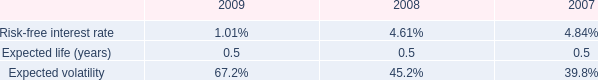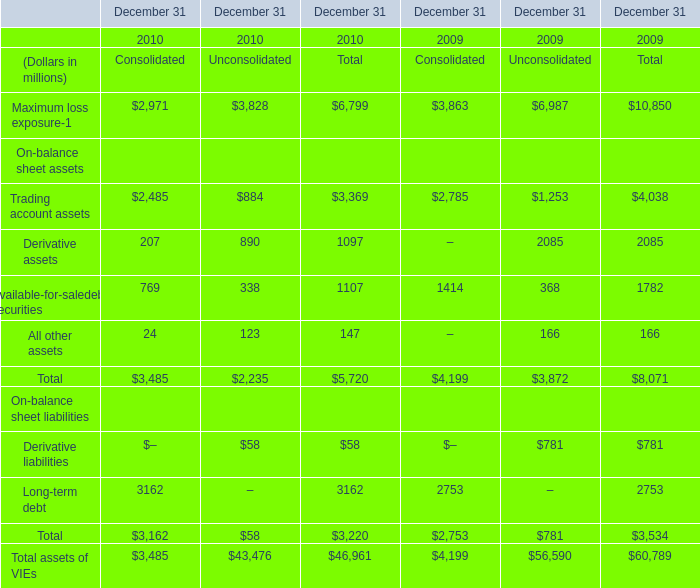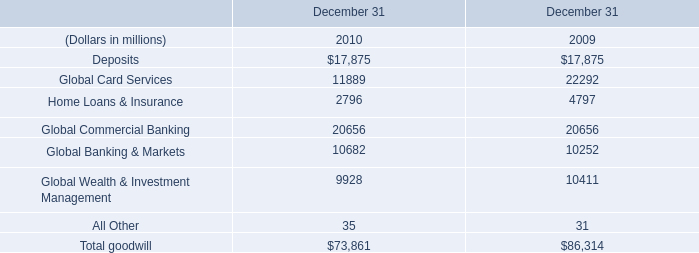What's the growth rate of Available-for-saledebt securities in unconsolidated in 2010? 
Computations: ((338 - 368) / 368)
Answer: -0.08152. 